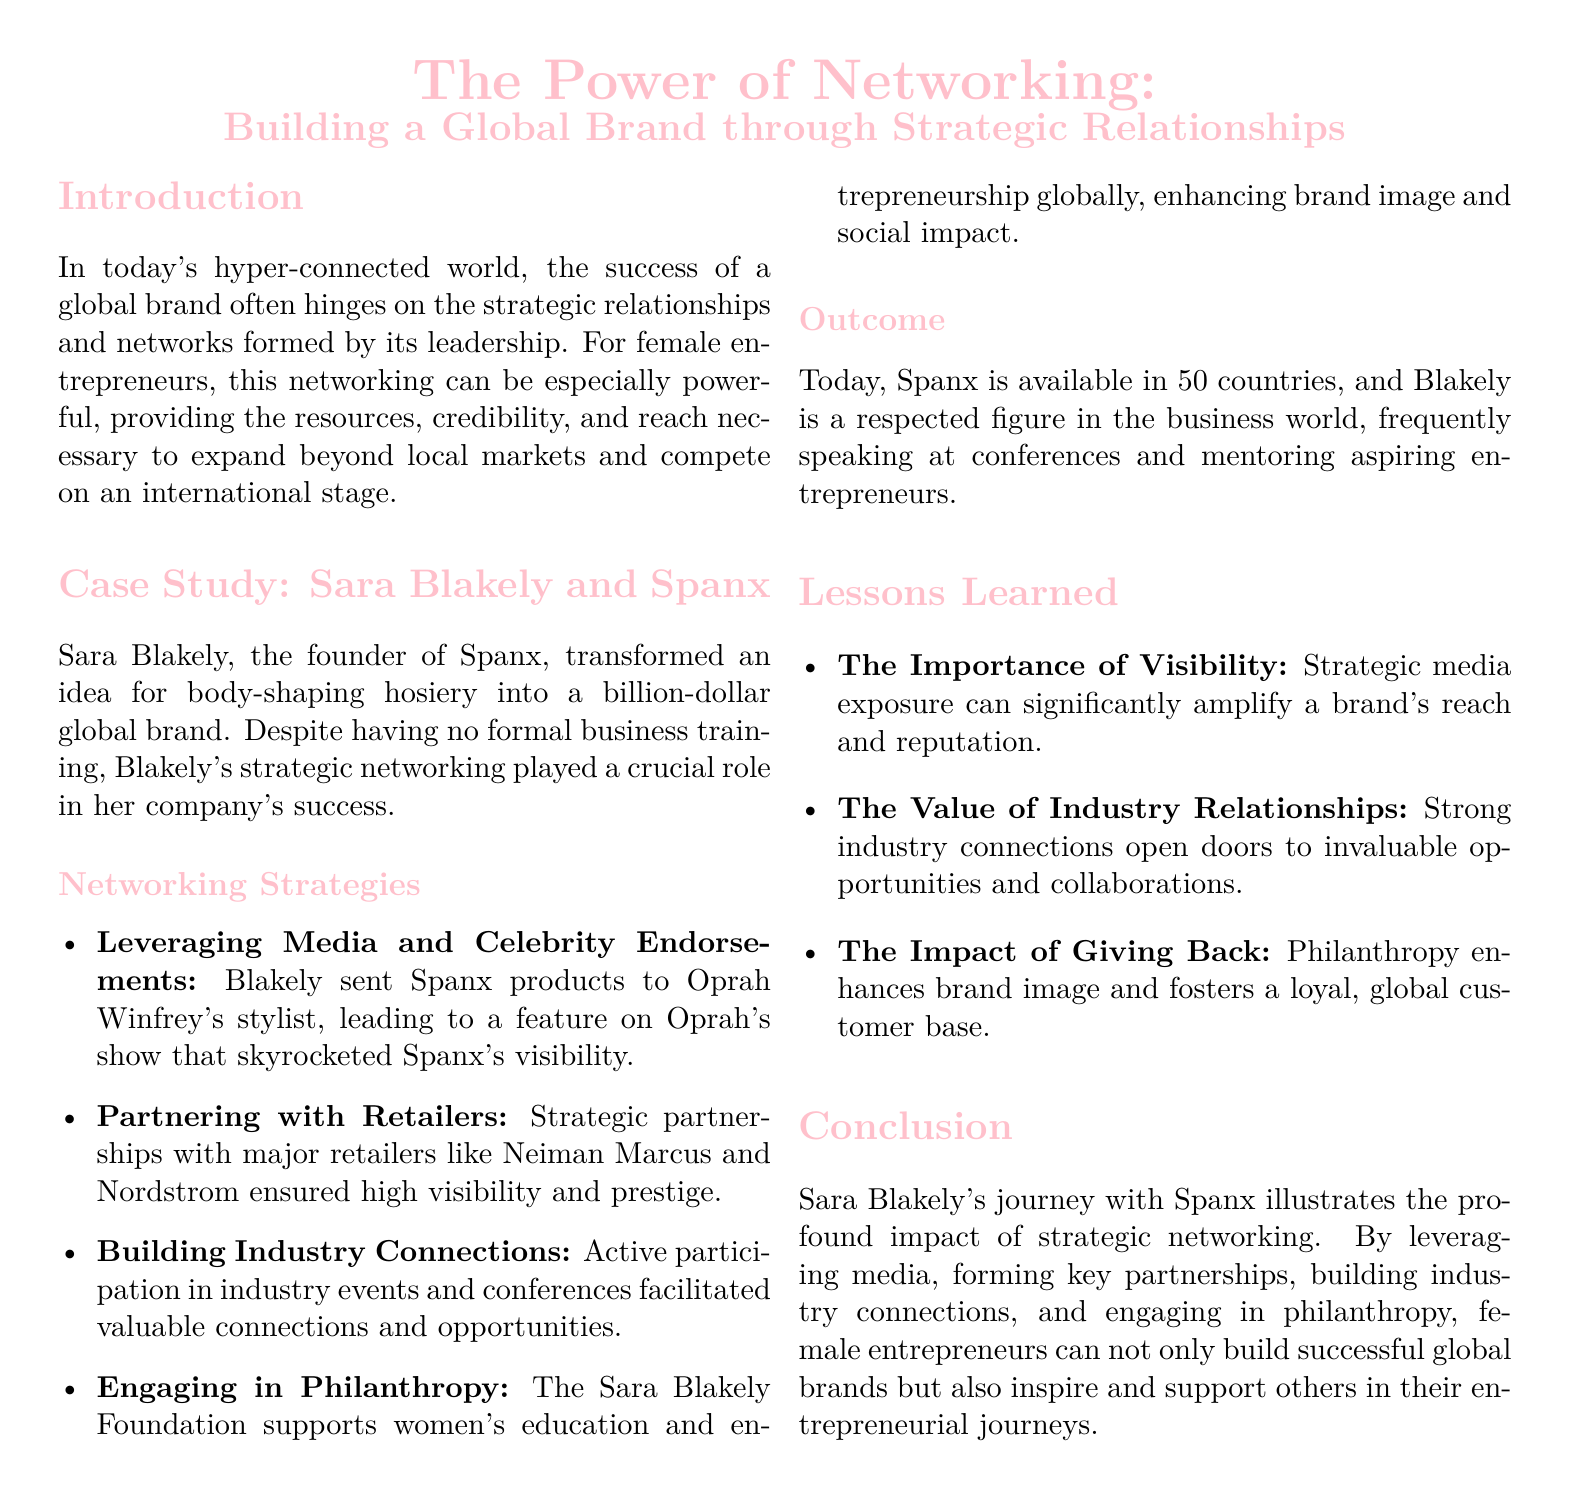What is the name of the founder of Spanx? The document mentions Sara Blakely as the founder of Spanx.
Answer: Sara Blakely In how many countries is Spanx available? The document states that Spanx is available in 50 countries.
Answer: 50 What was a key strategy used by Sara Blakely to increase Spanx's visibility? The document describes leveraging media and celebrity endorsements, specifically mentioning Oprah Winfrey.
Answer: Media and celebrity endorsements What kind of foundation did Sara Blakely establish? The document refers to the Sara Blakely Foundation, which supports women's education and entrepreneurship.
Answer: Sara Blakely Foundation What type of retailers did Spanx partner with to enhance visibility? The document lists major retailers like Neiman Marcus and Nordstrom as strategic partners.
Answer: Neiman Marcus and Nordstrom What is one lesson learned from Sara Blakely's journey? The document highlights the importance of visibility as a key lesson.
Answer: The importance of visibility How did philanthropy impact Spanx's brand image? The document indicates that philanthropy enhances brand image and fosters customer loyalty.
Answer: Enhances brand image What role does industry participation play in networking according to the case study? The document states that active participation in industry events facilitates valuable connections.
Answer: Valuable connections What is the primary focus of the Sara Blakely Foundation? The document mentions that it supports women's education and entrepreneurship globally.
Answer: Women's education and entrepreneurship 